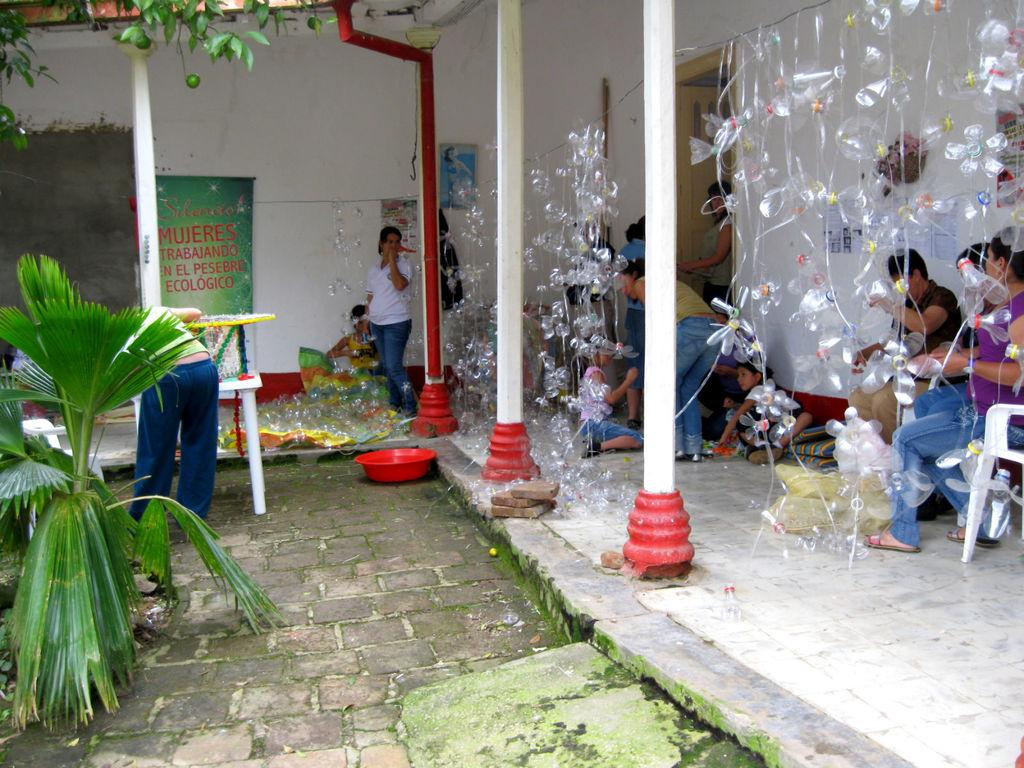What can be seen in the image related to people? There are people in the image. What is hanging in the image? The rope is hanging in the image, with bottles tied to it. What is located on the left side of the image? There is a plant, a banner, and a wall on the left side of the image. Can you tell me how many cans are visible in the image? There are no cans present in the image; it features bottles tied to a rope. What type of bear can be seen interacting with the people in the image? There is no bear present in the image; it only features people, bottles, a rope, a plant, a banner, and a wall. 